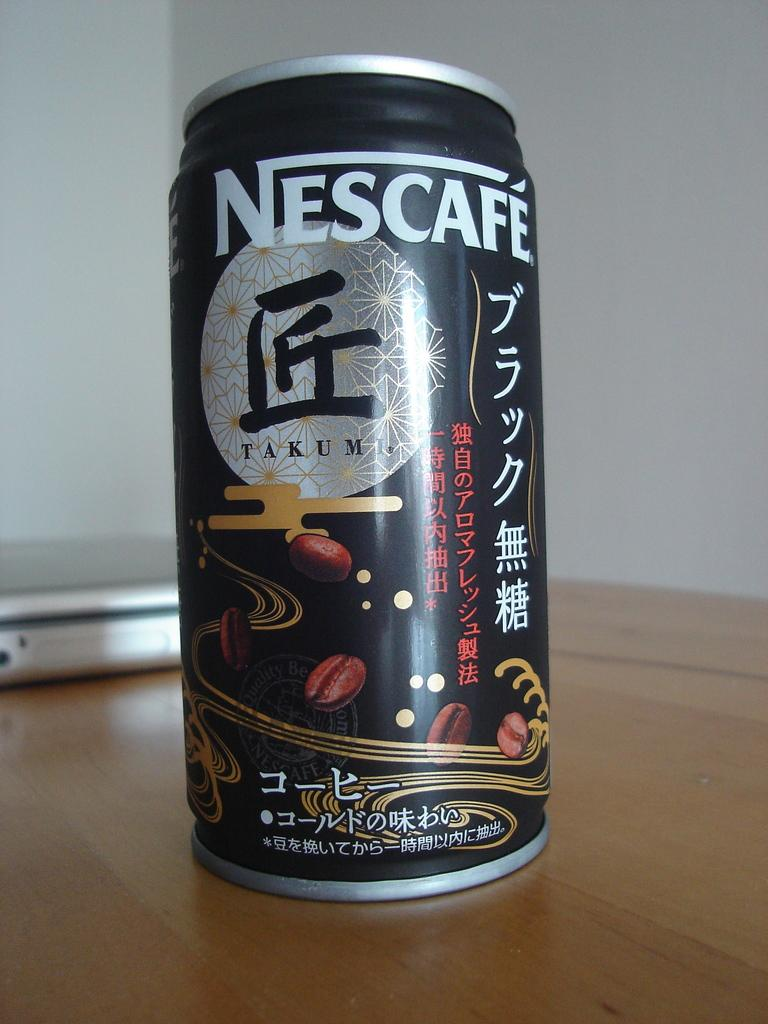What object can be seen in the image that is made of metal? There is a tin in the image that is made of metal. What other object can be seen in the image that is not made of metal? There is a device in the image that is not made of metal. Where are the tin and the device located in the image? Both the tin and the device are placed on a table in the image. What can be seen behind the objects in the image? There is a wall visible on the backside of the image. What type of riddle is written on the tin in the image? There is no riddle written on the tin in the image; it is a metal container. 